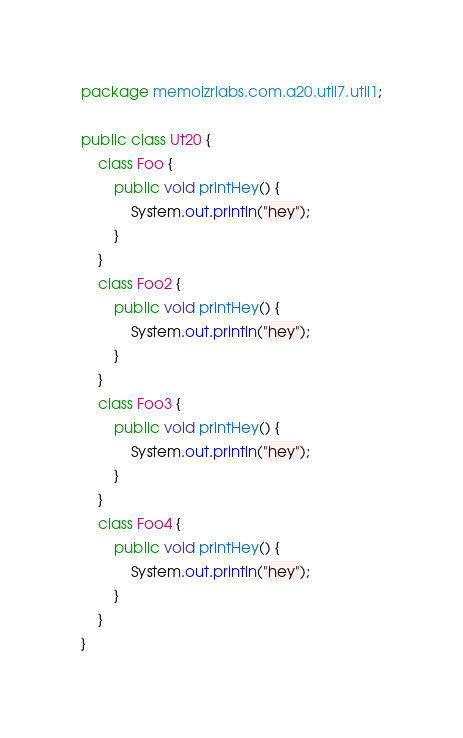Convert code to text. <code><loc_0><loc_0><loc_500><loc_500><_Java_>package memoizrlabs.com.a20.util7.util1;

public class Ut20 {
    class Foo {
        public void printHey() {
            System.out.println("hey");
        }
    }
    class Foo2 {
        public void printHey() {
            System.out.println("hey");
        }
    }
    class Foo3 {
        public void printHey() {
            System.out.println("hey");
        }
    }
    class Foo4 {
        public void printHey() {
            System.out.println("hey");
        }
    }
}
</code> 